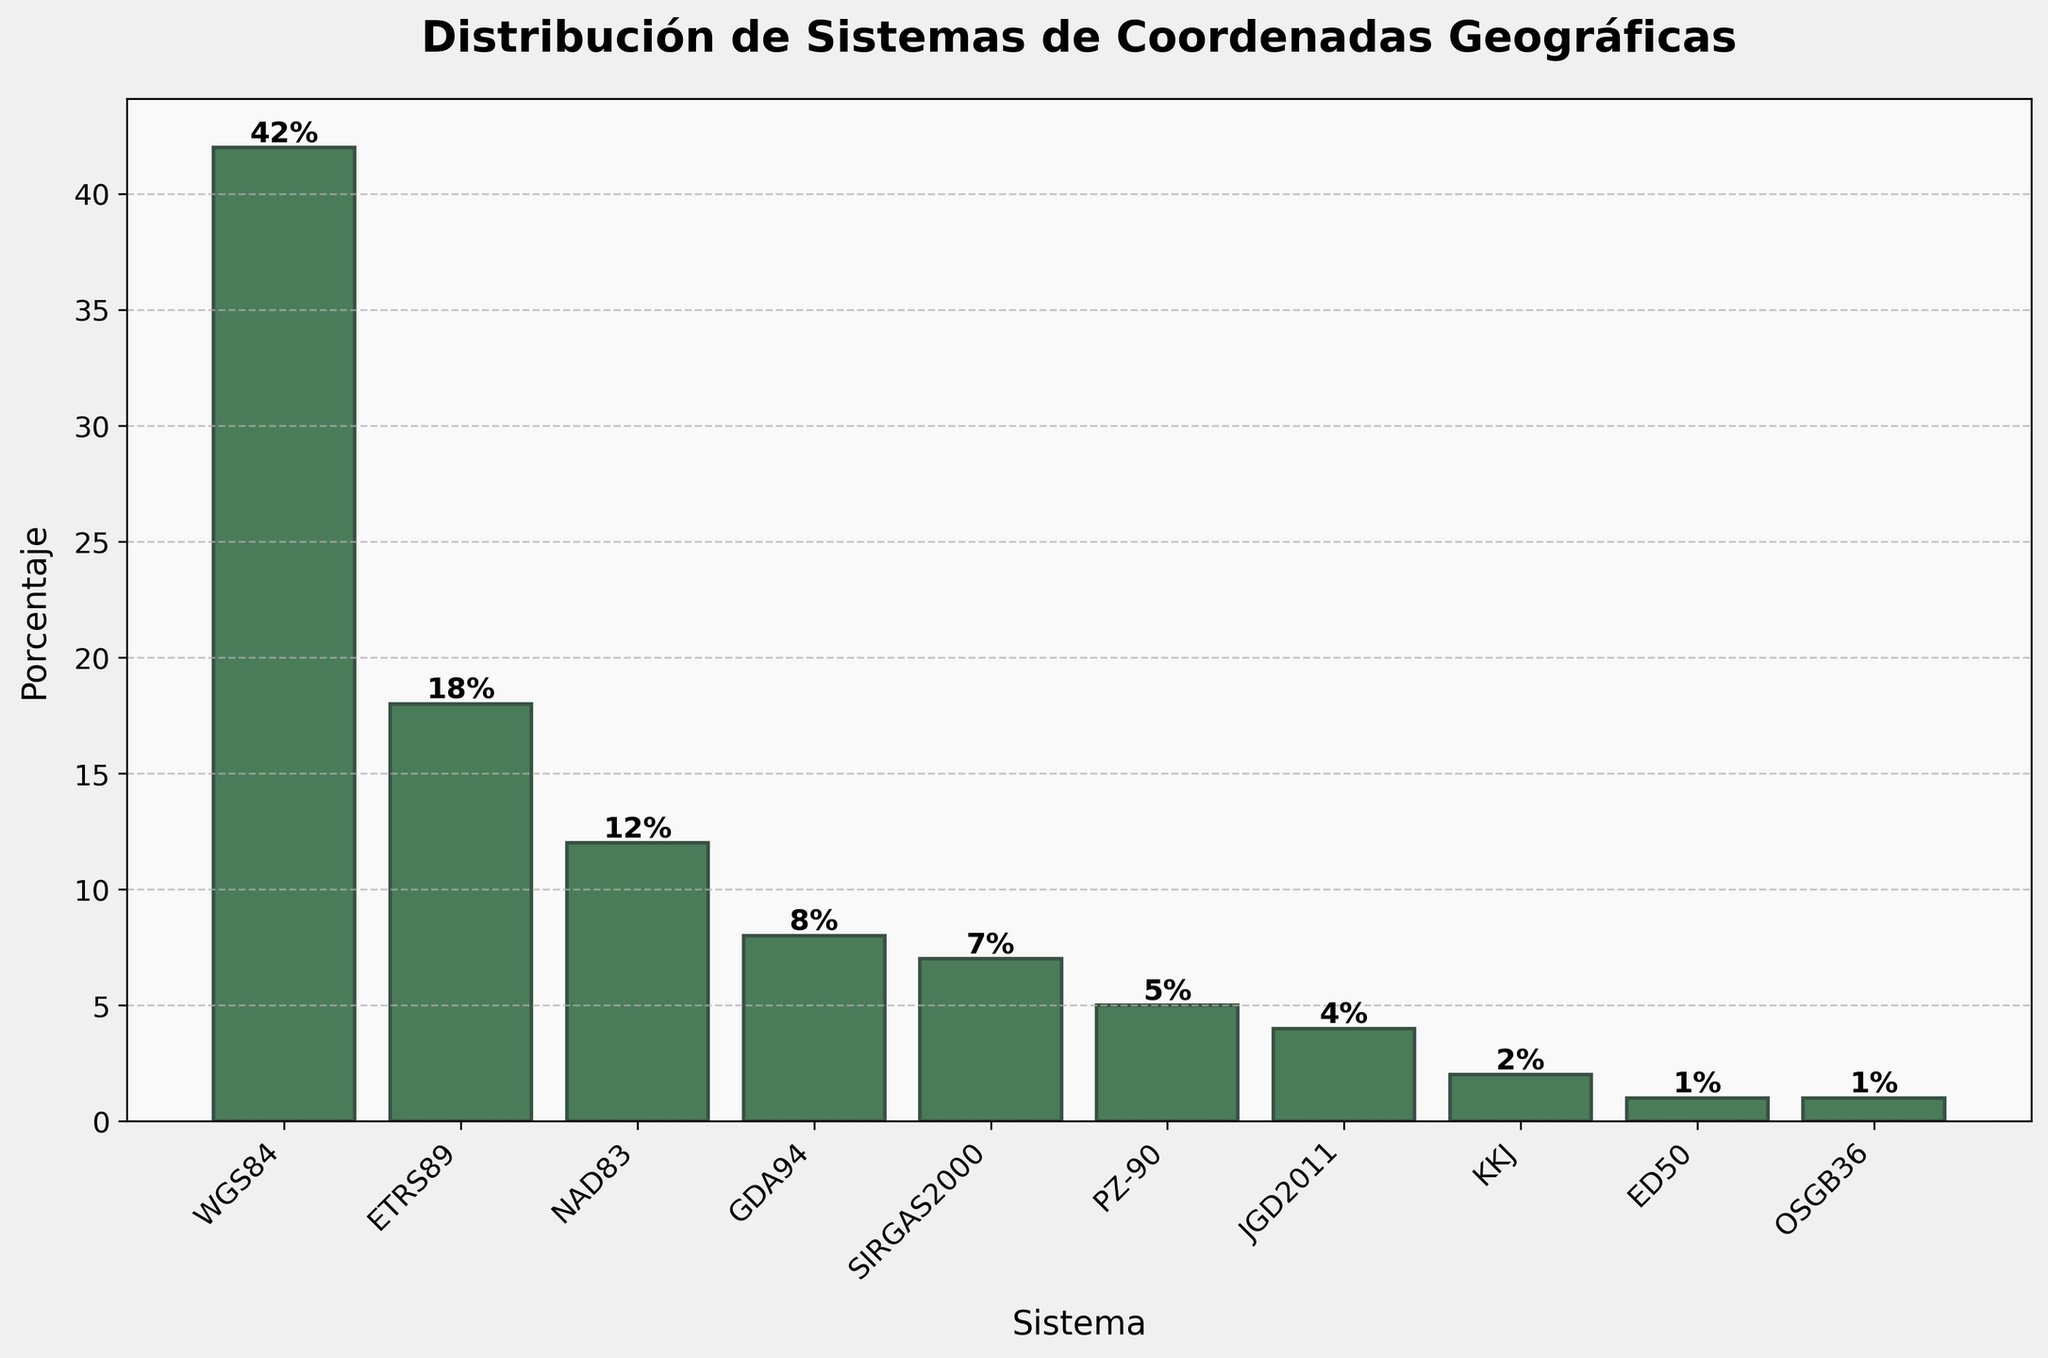¿Cuál es el sistema de coordenadas geográficas más utilizado en proyectos de geopy? Al observar la altura de las barras en el gráfico, la barra más alta corresponde al sistema "WGS84". La altura de esta barra indica el porcentaje más alto.
Answer: WGS84 ¿Cuáles son los sistemas de coordenadas geográficas menos utilizados, con un porcentaje del 1% cada uno? Al revisar las etiquetas y alturas de las barras en el gráfico, se puede ver que "ED50" y "OSGB36" son los sistemas que tienen una altura de 1%, lo que representa el menor porcentaje.
Answer: ED50 y OSGB36 ¿Cuál es la diferencia de porcentaje entre los sistemas de coordenadas geográficas WGS84 y ETRS89? La altura de la barra para WGS84 es 42% y para ETRS89 es 18%. Restando 18% a 42% se obtiene la diferencia.
Answer: 24% ¿Cuál es el porcentaje acumulado de los sistemas con porcentajes menores o iguales a 5%? Revisando las barras cuyo porcentaje es menor o igual a 5%, son PZ-90 (5%), JGD2011 (4%), KKJ (2%), ED50 (1%) y OSGB36 (1%). Sumando estos porcentajes se obtiene la acumulación: 5% + 4% + 2% + 1% + 1% = 13%.
Answer: 13% ¿Cuántos sistemas tienen un porcentaje mayor al del sistema GDA94? Según el gráfico, GDA94 tiene un porcentaje de 8%. Los sistemas con porcentajes mayores son WGS84 (42%), ETRS89 (18%) y NAD83 (12%). En total, hay 3 sistemas con un porcentaje mayor al de GDA94.
Answer: 3 ¿Cuál es la altura de la barra representando a SIRGAS2000 en comparación con la de NAD83? La altura de la barra para SIRGAS2000 es 7% y para NAD83 es 12%. Comparando estos valores, NAD83 es más alto que SIRGAS2000.
Answer: NAD83 es más alto ¿Cuál es el sistema de coordenadas cuya barra es del mismo color pero más corta que la de ETRS89? Al referenciar el color de las barras y la altura, la barra correspondiente a NAD83 es más corta que la de ETRS89, y están coloreadas de la misma manera.
Answer: NAD83 ¿Cuál es el sistema de coordenadas cuya barra se encuentra justo entre la de PZ-90 y la de KKJ? Observando la proximidad de ubicación de las barras en el gráfico, la barra de JGD2011 se encuentra entre las de PZ-90 y KKJ.
Answer: JGD2011 ¿Cuál es la segunda barra más baja del gráfico? La barra correspondiente a "OSGB36" tiene una altura del 1%, lo que la hace igual de baja que "ED50", pero es la segunda más baja en términos de posición en el gráfico.
Answer: OSGB36 